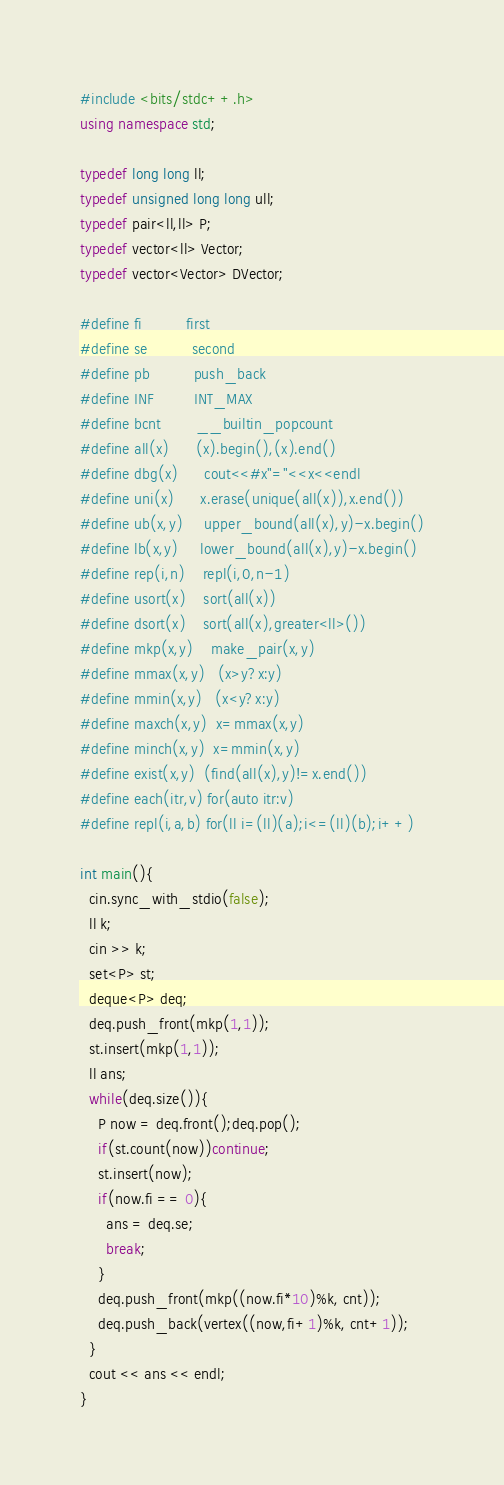Convert code to text. <code><loc_0><loc_0><loc_500><loc_500><_C++_>#include <bits/stdc++.h>
using namespace std;

typedef long long ll;
typedef unsigned long long ull;
typedef pair<ll,ll> P;
typedef vector<ll> Vector;
typedef vector<Vector> DVector;

#define fi          first
#define se          second
#define pb          push_back
#define INF         INT_MAX
#define bcnt        __builtin_popcount
#define all(x)      (x).begin(),(x).end()
#define dbg(x)      cout<<#x"="<<x<<endl
#define uni(x)      x.erase(unique(all(x)),x.end())
#define ub(x,y)     upper_bound(all(x),y)-x.begin()
#define lb(x,y)     lower_bound(all(x),y)-x.begin()
#define rep(i,n)    repl(i,0,n-1)
#define usort(x)    sort(all(x))
#define dsort(x)    sort(all(x),greater<ll>())
#define mkp(x,y)    make_pair(x,y)
#define mmax(x,y)   (x>y?x:y)
#define mmin(x,y)   (x<y?x:y)
#define maxch(x,y)  x=mmax(x,y)
#define minch(x,y)  x=mmin(x,y)
#define exist(x,y)  (find(all(x),y)!=x.end())
#define each(itr,v) for(auto itr:v)
#define repl(i,a,b) for(ll i=(ll)(a);i<=(ll)(b);i++)

int main(){
  cin.sync_with_stdio(false);
  ll k;
  cin >> k;
  set<P> st;
  deque<P> deq;
  deq.push_front(mkp(1,1));
  st.insert(mkp(1,1));
  ll ans;
  while(deq.size()){
    P now = deq.front();deq.pop();
    if(st.count(now))continue;
    st.insert(now);
    if(now.fi == 0){
      ans = deq.se;
      break;
    }
    deq.push_front(mkp((now.fi*10)%k, cnt));
    deq.push_back(vertex((now,fi+1)%k, cnt+1));
  }
  cout << ans << endl;
}
</code> 